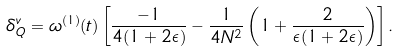Convert formula to latex. <formula><loc_0><loc_0><loc_500><loc_500>\delta ^ { v } _ { Q } = \omega ^ { ( 1 ) } ( t ) \left [ \frac { - 1 } { 4 ( 1 + 2 \epsilon ) } - \frac { 1 } { 4 N ^ { 2 } } \left ( 1 + \frac { 2 } { \epsilon ( 1 + 2 \epsilon ) } \right ) \right ] .</formula> 